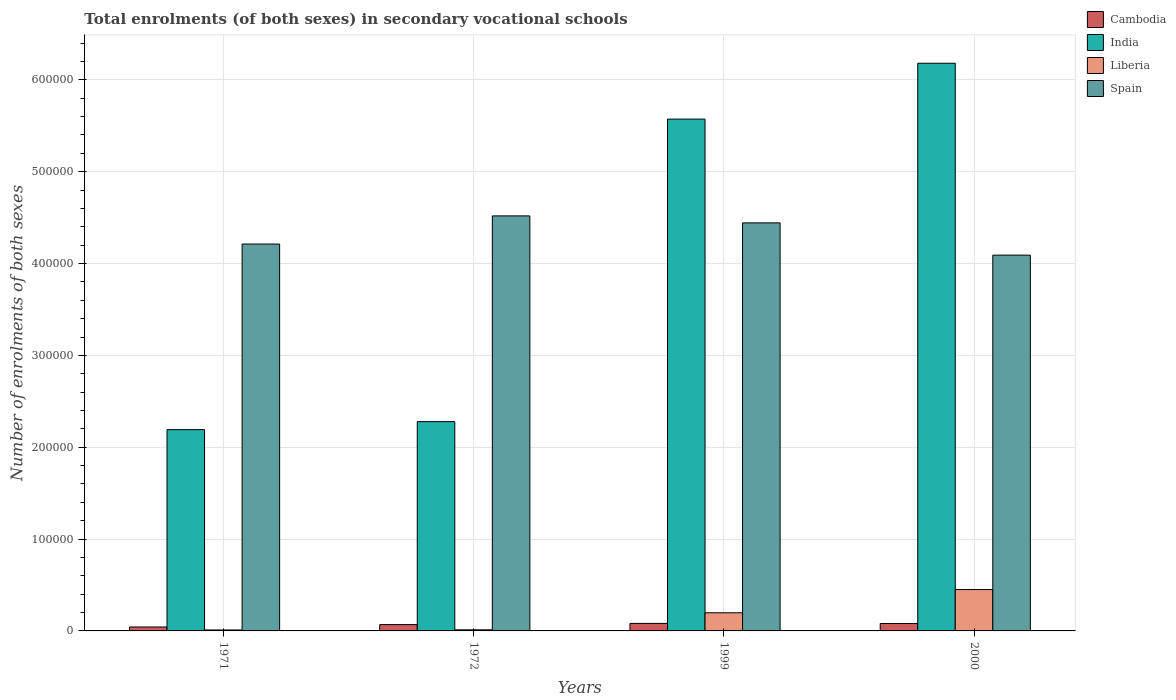How many different coloured bars are there?
Ensure brevity in your answer.  4. How many groups of bars are there?
Give a very brief answer. 4. What is the label of the 4th group of bars from the left?
Offer a terse response. 2000. What is the number of enrolments in secondary schools in India in 1999?
Give a very brief answer. 5.57e+05. Across all years, what is the maximum number of enrolments in secondary schools in Cambodia?
Ensure brevity in your answer.  8176. Across all years, what is the minimum number of enrolments in secondary schools in Liberia?
Give a very brief answer. 1053. In which year was the number of enrolments in secondary schools in Cambodia minimum?
Your answer should be very brief. 1971. What is the total number of enrolments in secondary schools in India in the graph?
Make the answer very short. 1.62e+06. What is the difference between the number of enrolments in secondary schools in India in 1971 and that in 2000?
Give a very brief answer. -3.99e+05. What is the difference between the number of enrolments in secondary schools in India in 1999 and the number of enrolments in secondary schools in Liberia in 1971?
Offer a terse response. 5.56e+05. What is the average number of enrolments in secondary schools in Cambodia per year?
Offer a very short reply. 6849.25. In the year 1971, what is the difference between the number of enrolments in secondary schools in India and number of enrolments in secondary schools in Liberia?
Ensure brevity in your answer.  2.18e+05. In how many years, is the number of enrolments in secondary schools in India greater than 100000?
Your answer should be very brief. 4. What is the ratio of the number of enrolments in secondary schools in Spain in 1971 to that in 1972?
Make the answer very short. 0.93. What is the difference between the highest and the second highest number of enrolments in secondary schools in India?
Your response must be concise. 6.08e+04. What is the difference between the highest and the lowest number of enrolments in secondary schools in Spain?
Ensure brevity in your answer.  4.27e+04. In how many years, is the number of enrolments in secondary schools in Cambodia greater than the average number of enrolments in secondary schools in Cambodia taken over all years?
Your response must be concise. 3. What does the 2nd bar from the right in 1999 represents?
Provide a short and direct response. Liberia. Is it the case that in every year, the sum of the number of enrolments in secondary schools in Cambodia and number of enrolments in secondary schools in Liberia is greater than the number of enrolments in secondary schools in Spain?
Keep it short and to the point. No. How many bars are there?
Offer a terse response. 16. Are all the bars in the graph horizontal?
Offer a terse response. No. What is the difference between two consecutive major ticks on the Y-axis?
Your answer should be compact. 1.00e+05. Does the graph contain any zero values?
Ensure brevity in your answer.  No. Where does the legend appear in the graph?
Give a very brief answer. Top right. How many legend labels are there?
Provide a short and direct response. 4. How are the legend labels stacked?
Provide a succinct answer. Vertical. What is the title of the graph?
Your answer should be compact. Total enrolments (of both sexes) in secondary vocational schools. Does "United States" appear as one of the legend labels in the graph?
Provide a succinct answer. No. What is the label or title of the Y-axis?
Provide a short and direct response. Number of enrolments of both sexes. What is the Number of enrolments of both sexes in Cambodia in 1971?
Ensure brevity in your answer.  4299. What is the Number of enrolments of both sexes of India in 1971?
Your response must be concise. 2.19e+05. What is the Number of enrolments of both sexes of Liberia in 1971?
Ensure brevity in your answer.  1053. What is the Number of enrolments of both sexes in Spain in 1971?
Your answer should be very brief. 4.21e+05. What is the Number of enrolments of both sexes in Cambodia in 1972?
Offer a terse response. 6873. What is the Number of enrolments of both sexes of India in 1972?
Give a very brief answer. 2.28e+05. What is the Number of enrolments of both sexes in Liberia in 1972?
Your answer should be compact. 1213. What is the Number of enrolments of both sexes in Spain in 1972?
Your answer should be very brief. 4.52e+05. What is the Number of enrolments of both sexes of Cambodia in 1999?
Your answer should be very brief. 8176. What is the Number of enrolments of both sexes of India in 1999?
Your answer should be very brief. 5.57e+05. What is the Number of enrolments of both sexes in Liberia in 1999?
Provide a short and direct response. 1.98e+04. What is the Number of enrolments of both sexes in Spain in 1999?
Make the answer very short. 4.44e+05. What is the Number of enrolments of both sexes of Cambodia in 2000?
Give a very brief answer. 8049. What is the Number of enrolments of both sexes of India in 2000?
Ensure brevity in your answer.  6.18e+05. What is the Number of enrolments of both sexes in Liberia in 2000?
Ensure brevity in your answer.  4.51e+04. What is the Number of enrolments of both sexes of Spain in 2000?
Ensure brevity in your answer.  4.09e+05. Across all years, what is the maximum Number of enrolments of both sexes of Cambodia?
Ensure brevity in your answer.  8176. Across all years, what is the maximum Number of enrolments of both sexes in India?
Your response must be concise. 6.18e+05. Across all years, what is the maximum Number of enrolments of both sexes in Liberia?
Your answer should be very brief. 4.51e+04. Across all years, what is the maximum Number of enrolments of both sexes in Spain?
Offer a very short reply. 4.52e+05. Across all years, what is the minimum Number of enrolments of both sexes in Cambodia?
Your answer should be compact. 4299. Across all years, what is the minimum Number of enrolments of both sexes of India?
Your response must be concise. 2.19e+05. Across all years, what is the minimum Number of enrolments of both sexes of Liberia?
Provide a short and direct response. 1053. Across all years, what is the minimum Number of enrolments of both sexes in Spain?
Your answer should be compact. 4.09e+05. What is the total Number of enrolments of both sexes of Cambodia in the graph?
Offer a terse response. 2.74e+04. What is the total Number of enrolments of both sexes in India in the graph?
Your answer should be compact. 1.62e+06. What is the total Number of enrolments of both sexes of Liberia in the graph?
Offer a terse response. 6.71e+04. What is the total Number of enrolments of both sexes of Spain in the graph?
Make the answer very short. 1.73e+06. What is the difference between the Number of enrolments of both sexes of Cambodia in 1971 and that in 1972?
Your response must be concise. -2574. What is the difference between the Number of enrolments of both sexes in India in 1971 and that in 1972?
Your answer should be very brief. -8699. What is the difference between the Number of enrolments of both sexes of Liberia in 1971 and that in 1972?
Offer a terse response. -160. What is the difference between the Number of enrolments of both sexes in Spain in 1971 and that in 1972?
Provide a short and direct response. -3.06e+04. What is the difference between the Number of enrolments of both sexes in Cambodia in 1971 and that in 1999?
Keep it short and to the point. -3877. What is the difference between the Number of enrolments of both sexes of India in 1971 and that in 1999?
Offer a very short reply. -3.38e+05. What is the difference between the Number of enrolments of both sexes in Liberia in 1971 and that in 1999?
Offer a terse response. -1.87e+04. What is the difference between the Number of enrolments of both sexes in Spain in 1971 and that in 1999?
Your answer should be compact. -2.30e+04. What is the difference between the Number of enrolments of both sexes in Cambodia in 1971 and that in 2000?
Offer a very short reply. -3750. What is the difference between the Number of enrolments of both sexes of India in 1971 and that in 2000?
Provide a succinct answer. -3.99e+05. What is the difference between the Number of enrolments of both sexes of Liberia in 1971 and that in 2000?
Your response must be concise. -4.40e+04. What is the difference between the Number of enrolments of both sexes of Spain in 1971 and that in 2000?
Your answer should be compact. 1.21e+04. What is the difference between the Number of enrolments of both sexes of Cambodia in 1972 and that in 1999?
Provide a short and direct response. -1303. What is the difference between the Number of enrolments of both sexes in India in 1972 and that in 1999?
Offer a terse response. -3.29e+05. What is the difference between the Number of enrolments of both sexes of Liberia in 1972 and that in 1999?
Keep it short and to the point. -1.85e+04. What is the difference between the Number of enrolments of both sexes of Spain in 1972 and that in 1999?
Give a very brief answer. 7599. What is the difference between the Number of enrolments of both sexes in Cambodia in 1972 and that in 2000?
Your answer should be compact. -1176. What is the difference between the Number of enrolments of both sexes in India in 1972 and that in 2000?
Ensure brevity in your answer.  -3.90e+05. What is the difference between the Number of enrolments of both sexes in Liberia in 1972 and that in 2000?
Provide a succinct answer. -4.39e+04. What is the difference between the Number of enrolments of both sexes in Spain in 1972 and that in 2000?
Offer a terse response. 4.27e+04. What is the difference between the Number of enrolments of both sexes in Cambodia in 1999 and that in 2000?
Your answer should be compact. 127. What is the difference between the Number of enrolments of both sexes in India in 1999 and that in 2000?
Make the answer very short. -6.08e+04. What is the difference between the Number of enrolments of both sexes of Liberia in 1999 and that in 2000?
Offer a very short reply. -2.53e+04. What is the difference between the Number of enrolments of both sexes of Spain in 1999 and that in 2000?
Offer a very short reply. 3.51e+04. What is the difference between the Number of enrolments of both sexes in Cambodia in 1971 and the Number of enrolments of both sexes in India in 1972?
Provide a short and direct response. -2.24e+05. What is the difference between the Number of enrolments of both sexes of Cambodia in 1971 and the Number of enrolments of both sexes of Liberia in 1972?
Offer a terse response. 3086. What is the difference between the Number of enrolments of both sexes in Cambodia in 1971 and the Number of enrolments of both sexes in Spain in 1972?
Your answer should be compact. -4.48e+05. What is the difference between the Number of enrolments of both sexes in India in 1971 and the Number of enrolments of both sexes in Liberia in 1972?
Provide a succinct answer. 2.18e+05. What is the difference between the Number of enrolments of both sexes in India in 1971 and the Number of enrolments of both sexes in Spain in 1972?
Your answer should be very brief. -2.33e+05. What is the difference between the Number of enrolments of both sexes of Liberia in 1971 and the Number of enrolments of both sexes of Spain in 1972?
Provide a short and direct response. -4.51e+05. What is the difference between the Number of enrolments of both sexes of Cambodia in 1971 and the Number of enrolments of both sexes of India in 1999?
Offer a terse response. -5.53e+05. What is the difference between the Number of enrolments of both sexes in Cambodia in 1971 and the Number of enrolments of both sexes in Liberia in 1999?
Provide a succinct answer. -1.55e+04. What is the difference between the Number of enrolments of both sexes in Cambodia in 1971 and the Number of enrolments of both sexes in Spain in 1999?
Your answer should be very brief. -4.40e+05. What is the difference between the Number of enrolments of both sexes of India in 1971 and the Number of enrolments of both sexes of Liberia in 1999?
Give a very brief answer. 1.99e+05. What is the difference between the Number of enrolments of both sexes of India in 1971 and the Number of enrolments of both sexes of Spain in 1999?
Offer a very short reply. -2.25e+05. What is the difference between the Number of enrolments of both sexes of Liberia in 1971 and the Number of enrolments of both sexes of Spain in 1999?
Keep it short and to the point. -4.43e+05. What is the difference between the Number of enrolments of both sexes of Cambodia in 1971 and the Number of enrolments of both sexes of India in 2000?
Offer a very short reply. -6.14e+05. What is the difference between the Number of enrolments of both sexes of Cambodia in 1971 and the Number of enrolments of both sexes of Liberia in 2000?
Offer a terse response. -4.08e+04. What is the difference between the Number of enrolments of both sexes in Cambodia in 1971 and the Number of enrolments of both sexes in Spain in 2000?
Your response must be concise. -4.05e+05. What is the difference between the Number of enrolments of both sexes of India in 1971 and the Number of enrolments of both sexes of Liberia in 2000?
Provide a short and direct response. 1.74e+05. What is the difference between the Number of enrolments of both sexes of India in 1971 and the Number of enrolments of both sexes of Spain in 2000?
Provide a short and direct response. -1.90e+05. What is the difference between the Number of enrolments of both sexes in Liberia in 1971 and the Number of enrolments of both sexes in Spain in 2000?
Offer a very short reply. -4.08e+05. What is the difference between the Number of enrolments of both sexes in Cambodia in 1972 and the Number of enrolments of both sexes in India in 1999?
Ensure brevity in your answer.  -5.50e+05. What is the difference between the Number of enrolments of both sexes in Cambodia in 1972 and the Number of enrolments of both sexes in Liberia in 1999?
Keep it short and to the point. -1.29e+04. What is the difference between the Number of enrolments of both sexes in Cambodia in 1972 and the Number of enrolments of both sexes in Spain in 1999?
Your answer should be very brief. -4.37e+05. What is the difference between the Number of enrolments of both sexes of India in 1972 and the Number of enrolments of both sexes of Liberia in 1999?
Offer a very short reply. 2.08e+05. What is the difference between the Number of enrolments of both sexes of India in 1972 and the Number of enrolments of both sexes of Spain in 1999?
Your response must be concise. -2.16e+05. What is the difference between the Number of enrolments of both sexes in Liberia in 1972 and the Number of enrolments of both sexes in Spain in 1999?
Ensure brevity in your answer.  -4.43e+05. What is the difference between the Number of enrolments of both sexes of Cambodia in 1972 and the Number of enrolments of both sexes of India in 2000?
Make the answer very short. -6.11e+05. What is the difference between the Number of enrolments of both sexes in Cambodia in 1972 and the Number of enrolments of both sexes in Liberia in 2000?
Offer a terse response. -3.82e+04. What is the difference between the Number of enrolments of both sexes of Cambodia in 1972 and the Number of enrolments of both sexes of Spain in 2000?
Make the answer very short. -4.02e+05. What is the difference between the Number of enrolments of both sexes of India in 1972 and the Number of enrolments of both sexes of Liberia in 2000?
Keep it short and to the point. 1.83e+05. What is the difference between the Number of enrolments of both sexes in India in 1972 and the Number of enrolments of both sexes in Spain in 2000?
Ensure brevity in your answer.  -1.81e+05. What is the difference between the Number of enrolments of both sexes in Liberia in 1972 and the Number of enrolments of both sexes in Spain in 2000?
Ensure brevity in your answer.  -4.08e+05. What is the difference between the Number of enrolments of both sexes in Cambodia in 1999 and the Number of enrolments of both sexes in India in 2000?
Provide a succinct answer. -6.10e+05. What is the difference between the Number of enrolments of both sexes in Cambodia in 1999 and the Number of enrolments of both sexes in Liberia in 2000?
Make the answer very short. -3.69e+04. What is the difference between the Number of enrolments of both sexes of Cambodia in 1999 and the Number of enrolments of both sexes of Spain in 2000?
Make the answer very short. -4.01e+05. What is the difference between the Number of enrolments of both sexes of India in 1999 and the Number of enrolments of both sexes of Liberia in 2000?
Your answer should be very brief. 5.12e+05. What is the difference between the Number of enrolments of both sexes of India in 1999 and the Number of enrolments of both sexes of Spain in 2000?
Make the answer very short. 1.48e+05. What is the difference between the Number of enrolments of both sexes of Liberia in 1999 and the Number of enrolments of both sexes of Spain in 2000?
Your response must be concise. -3.89e+05. What is the average Number of enrolments of both sexes of Cambodia per year?
Provide a short and direct response. 6849.25. What is the average Number of enrolments of both sexes in India per year?
Keep it short and to the point. 4.06e+05. What is the average Number of enrolments of both sexes of Liberia per year?
Your answer should be very brief. 1.68e+04. What is the average Number of enrolments of both sexes in Spain per year?
Your answer should be compact. 4.32e+05. In the year 1971, what is the difference between the Number of enrolments of both sexes of Cambodia and Number of enrolments of both sexes of India?
Your answer should be very brief. -2.15e+05. In the year 1971, what is the difference between the Number of enrolments of both sexes in Cambodia and Number of enrolments of both sexes in Liberia?
Your response must be concise. 3246. In the year 1971, what is the difference between the Number of enrolments of both sexes in Cambodia and Number of enrolments of both sexes in Spain?
Give a very brief answer. -4.17e+05. In the year 1971, what is the difference between the Number of enrolments of both sexes in India and Number of enrolments of both sexes in Liberia?
Your answer should be compact. 2.18e+05. In the year 1971, what is the difference between the Number of enrolments of both sexes of India and Number of enrolments of both sexes of Spain?
Your response must be concise. -2.02e+05. In the year 1971, what is the difference between the Number of enrolments of both sexes of Liberia and Number of enrolments of both sexes of Spain?
Make the answer very short. -4.20e+05. In the year 1972, what is the difference between the Number of enrolments of both sexes of Cambodia and Number of enrolments of both sexes of India?
Provide a short and direct response. -2.21e+05. In the year 1972, what is the difference between the Number of enrolments of both sexes of Cambodia and Number of enrolments of both sexes of Liberia?
Your answer should be compact. 5660. In the year 1972, what is the difference between the Number of enrolments of both sexes in Cambodia and Number of enrolments of both sexes in Spain?
Give a very brief answer. -4.45e+05. In the year 1972, what is the difference between the Number of enrolments of both sexes of India and Number of enrolments of both sexes of Liberia?
Provide a short and direct response. 2.27e+05. In the year 1972, what is the difference between the Number of enrolments of both sexes in India and Number of enrolments of both sexes in Spain?
Keep it short and to the point. -2.24e+05. In the year 1972, what is the difference between the Number of enrolments of both sexes of Liberia and Number of enrolments of both sexes of Spain?
Your response must be concise. -4.51e+05. In the year 1999, what is the difference between the Number of enrolments of both sexes of Cambodia and Number of enrolments of both sexes of India?
Offer a very short reply. -5.49e+05. In the year 1999, what is the difference between the Number of enrolments of both sexes of Cambodia and Number of enrolments of both sexes of Liberia?
Ensure brevity in your answer.  -1.16e+04. In the year 1999, what is the difference between the Number of enrolments of both sexes in Cambodia and Number of enrolments of both sexes in Spain?
Offer a very short reply. -4.36e+05. In the year 1999, what is the difference between the Number of enrolments of both sexes in India and Number of enrolments of both sexes in Liberia?
Provide a succinct answer. 5.38e+05. In the year 1999, what is the difference between the Number of enrolments of both sexes of India and Number of enrolments of both sexes of Spain?
Give a very brief answer. 1.13e+05. In the year 1999, what is the difference between the Number of enrolments of both sexes of Liberia and Number of enrolments of both sexes of Spain?
Make the answer very short. -4.25e+05. In the year 2000, what is the difference between the Number of enrolments of both sexes of Cambodia and Number of enrolments of both sexes of India?
Provide a succinct answer. -6.10e+05. In the year 2000, what is the difference between the Number of enrolments of both sexes in Cambodia and Number of enrolments of both sexes in Liberia?
Keep it short and to the point. -3.70e+04. In the year 2000, what is the difference between the Number of enrolments of both sexes of Cambodia and Number of enrolments of both sexes of Spain?
Provide a succinct answer. -4.01e+05. In the year 2000, what is the difference between the Number of enrolments of both sexes in India and Number of enrolments of both sexes in Liberia?
Give a very brief answer. 5.73e+05. In the year 2000, what is the difference between the Number of enrolments of both sexes of India and Number of enrolments of both sexes of Spain?
Your answer should be compact. 2.09e+05. In the year 2000, what is the difference between the Number of enrolments of both sexes of Liberia and Number of enrolments of both sexes of Spain?
Keep it short and to the point. -3.64e+05. What is the ratio of the Number of enrolments of both sexes of Cambodia in 1971 to that in 1972?
Offer a very short reply. 0.63. What is the ratio of the Number of enrolments of both sexes of India in 1971 to that in 1972?
Your response must be concise. 0.96. What is the ratio of the Number of enrolments of both sexes in Liberia in 1971 to that in 1972?
Offer a very short reply. 0.87. What is the ratio of the Number of enrolments of both sexes in Spain in 1971 to that in 1972?
Give a very brief answer. 0.93. What is the ratio of the Number of enrolments of both sexes of Cambodia in 1971 to that in 1999?
Offer a terse response. 0.53. What is the ratio of the Number of enrolments of both sexes of India in 1971 to that in 1999?
Your answer should be compact. 0.39. What is the ratio of the Number of enrolments of both sexes of Liberia in 1971 to that in 1999?
Make the answer very short. 0.05. What is the ratio of the Number of enrolments of both sexes in Spain in 1971 to that in 1999?
Provide a succinct answer. 0.95. What is the ratio of the Number of enrolments of both sexes of Cambodia in 1971 to that in 2000?
Your answer should be very brief. 0.53. What is the ratio of the Number of enrolments of both sexes of India in 1971 to that in 2000?
Your response must be concise. 0.35. What is the ratio of the Number of enrolments of both sexes in Liberia in 1971 to that in 2000?
Offer a terse response. 0.02. What is the ratio of the Number of enrolments of both sexes in Spain in 1971 to that in 2000?
Offer a terse response. 1.03. What is the ratio of the Number of enrolments of both sexes of Cambodia in 1972 to that in 1999?
Provide a short and direct response. 0.84. What is the ratio of the Number of enrolments of both sexes of India in 1972 to that in 1999?
Your response must be concise. 0.41. What is the ratio of the Number of enrolments of both sexes of Liberia in 1972 to that in 1999?
Give a very brief answer. 0.06. What is the ratio of the Number of enrolments of both sexes in Spain in 1972 to that in 1999?
Make the answer very short. 1.02. What is the ratio of the Number of enrolments of both sexes of Cambodia in 1972 to that in 2000?
Offer a very short reply. 0.85. What is the ratio of the Number of enrolments of both sexes in India in 1972 to that in 2000?
Your response must be concise. 0.37. What is the ratio of the Number of enrolments of both sexes of Liberia in 1972 to that in 2000?
Your answer should be compact. 0.03. What is the ratio of the Number of enrolments of both sexes of Spain in 1972 to that in 2000?
Your answer should be very brief. 1.1. What is the ratio of the Number of enrolments of both sexes in Cambodia in 1999 to that in 2000?
Offer a terse response. 1.02. What is the ratio of the Number of enrolments of both sexes of India in 1999 to that in 2000?
Provide a succinct answer. 0.9. What is the ratio of the Number of enrolments of both sexes of Liberia in 1999 to that in 2000?
Provide a short and direct response. 0.44. What is the ratio of the Number of enrolments of both sexes of Spain in 1999 to that in 2000?
Your response must be concise. 1.09. What is the difference between the highest and the second highest Number of enrolments of both sexes in Cambodia?
Your answer should be very brief. 127. What is the difference between the highest and the second highest Number of enrolments of both sexes in India?
Provide a short and direct response. 6.08e+04. What is the difference between the highest and the second highest Number of enrolments of both sexes in Liberia?
Keep it short and to the point. 2.53e+04. What is the difference between the highest and the second highest Number of enrolments of both sexes in Spain?
Give a very brief answer. 7599. What is the difference between the highest and the lowest Number of enrolments of both sexes of Cambodia?
Provide a succinct answer. 3877. What is the difference between the highest and the lowest Number of enrolments of both sexes of India?
Provide a succinct answer. 3.99e+05. What is the difference between the highest and the lowest Number of enrolments of both sexes in Liberia?
Your answer should be compact. 4.40e+04. What is the difference between the highest and the lowest Number of enrolments of both sexes of Spain?
Ensure brevity in your answer.  4.27e+04. 